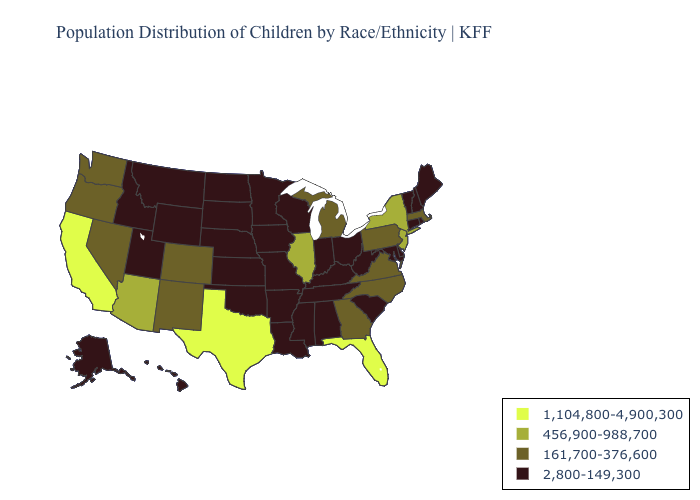What is the value of Florida?
Short answer required. 1,104,800-4,900,300. Name the states that have a value in the range 2,800-149,300?
Write a very short answer. Alabama, Alaska, Arkansas, Connecticut, Delaware, Hawaii, Idaho, Indiana, Iowa, Kansas, Kentucky, Louisiana, Maine, Maryland, Minnesota, Mississippi, Missouri, Montana, Nebraska, New Hampshire, North Dakota, Ohio, Oklahoma, Rhode Island, South Carolina, South Dakota, Tennessee, Utah, Vermont, West Virginia, Wisconsin, Wyoming. Name the states that have a value in the range 456,900-988,700?
Answer briefly. Arizona, Illinois, New Jersey, New York. Name the states that have a value in the range 1,104,800-4,900,300?
Concise answer only. California, Florida, Texas. Does the first symbol in the legend represent the smallest category?
Quick response, please. No. What is the value of West Virginia?
Give a very brief answer. 2,800-149,300. Name the states that have a value in the range 1,104,800-4,900,300?
Keep it brief. California, Florida, Texas. Does South Dakota have the same value as North Dakota?
Quick response, please. Yes. Which states have the highest value in the USA?
Be succinct. California, Florida, Texas. What is the value of New Jersey?
Write a very short answer. 456,900-988,700. What is the value of New York?
Write a very short answer. 456,900-988,700. Name the states that have a value in the range 161,700-376,600?
Short answer required. Colorado, Georgia, Massachusetts, Michigan, Nevada, New Mexico, North Carolina, Oregon, Pennsylvania, Virginia, Washington. What is the value of Louisiana?
Quick response, please. 2,800-149,300. Among the states that border New Hampshire , does Massachusetts have the lowest value?
Keep it brief. No. What is the value of Maine?
Answer briefly. 2,800-149,300. 